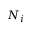<formula> <loc_0><loc_0><loc_500><loc_500>N _ { i }</formula> 